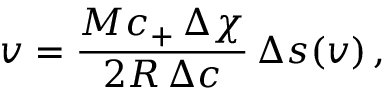Convert formula to latex. <formula><loc_0><loc_0><loc_500><loc_500>v = \frac { M c _ { + } \, \Delta \chi } { 2 R \, \Delta c } \, \Delta s ( v ) \, ,</formula> 